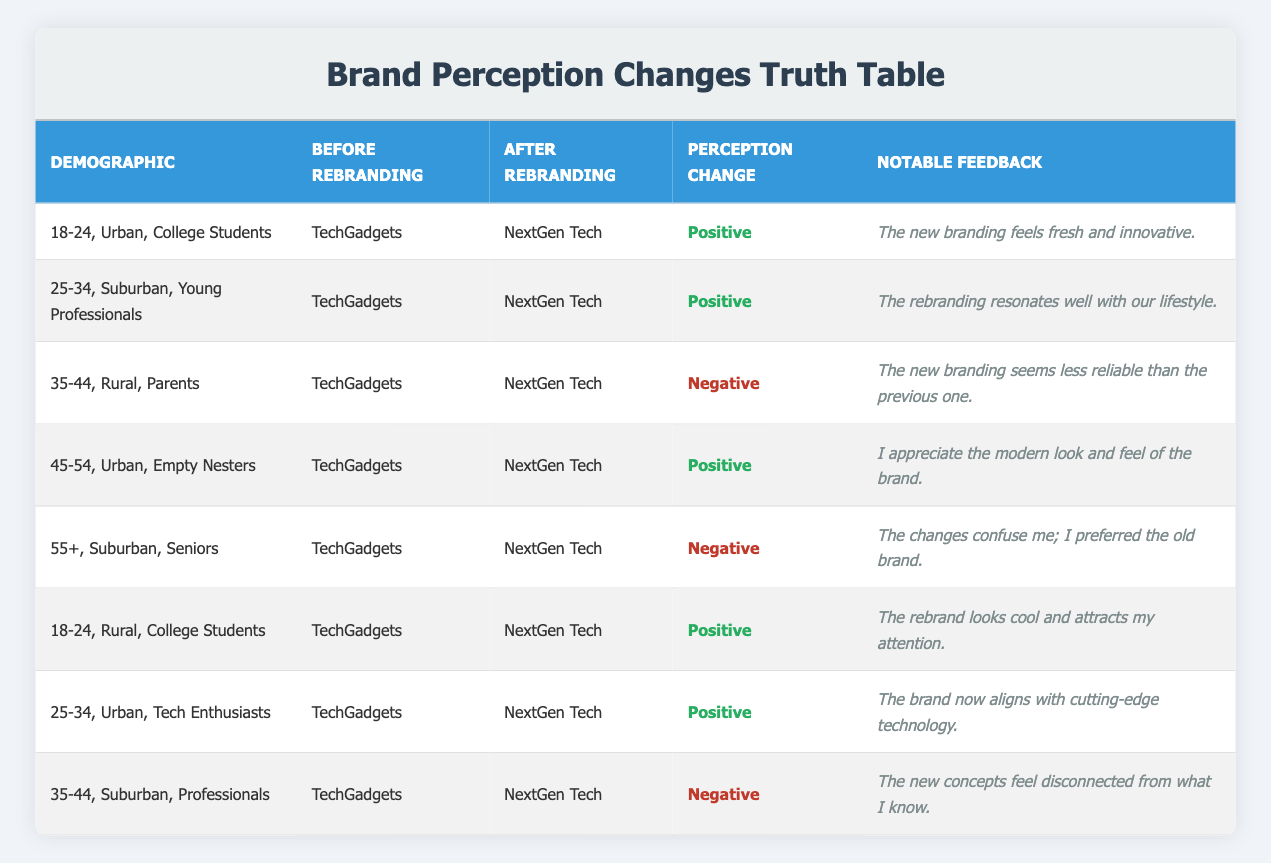What is the notable feedback from the demographic "35-44, Rural, Parents"? According to the table, the notable feedback from this demographic is "The new branding seems less reliable than the previous one." This information can be found in the corresponding row under the "Notable Feedback" column for that demographic.
Answer: The new branding seems less reliable than the previous one How many demographics experienced a negative perception change after the rebranding? By reviewing the "Perception Change" column, I see that there are three instances marked as negative: "35-44, Rural, Parents", "55+, Suburban, Seniors", and "35-44, Suburban, Professionals". Therefore, the total is counted as three.
Answer: Three demographics experienced a negative perception change Did any demographics report a perception change that was both positive and negative? Looking through the rows, each demographic either reported a positive or negative perception change but not both in the same row. Thus, no demographic reflects both a positive and negative change.
Answer: No demographics reported a change that was both positive and negative Which demographic had the most positive feedback regarding the rebranding? The demographic "25-34, Urban, Tech Enthusiasts" reported that "The brand now aligns with cutting-edge technology." This is a strong positive statement reflecting satisfaction, and thus can be considered among the most positive feedback.
Answer: 25-34, Urban, Tech Enthusiasts What percentage of the demographics experienced positive perception changes after rebranding? There are 8 demographics total. Five of them reported a positive change. To find the percentage, the formula is (number of positive changes/total demographics) * 100 = (5/8) * 100 = 62.5%. This provides a clear understanding of the ratio of positive feedback.
Answer: 62.5% What kind of notable feedback did "18-24, Rural, College Students" provide after rebranding? According to the table, this demographic noted that "The rebrand looks cool and attracts my attention." This feedback indicates a favorable shift in their perception of the brand.
Answer: The rebrand looks cool and attracts my attention In which demographic did feedback indicate confusion due to the rebranding changes? The feedback from "55+, Suburban, Seniors" indicates confusion, stating "The changes confuse me; I preferred the old brand." This feedback highlights dissatisfaction with the rebranding.
Answer: 55+, Suburban, Seniors Was there any demographic that had a perception change listed as negative and specifically mentioned disconnection from previous knowledge? Yes, the demographic "35-44, Suburban, Professionals" reported a negative change with the feedback saying, "The new concepts feel disconnected from what I know." This demonstrates a clear feeling of disconnection after rebranding.
Answer: Yes 